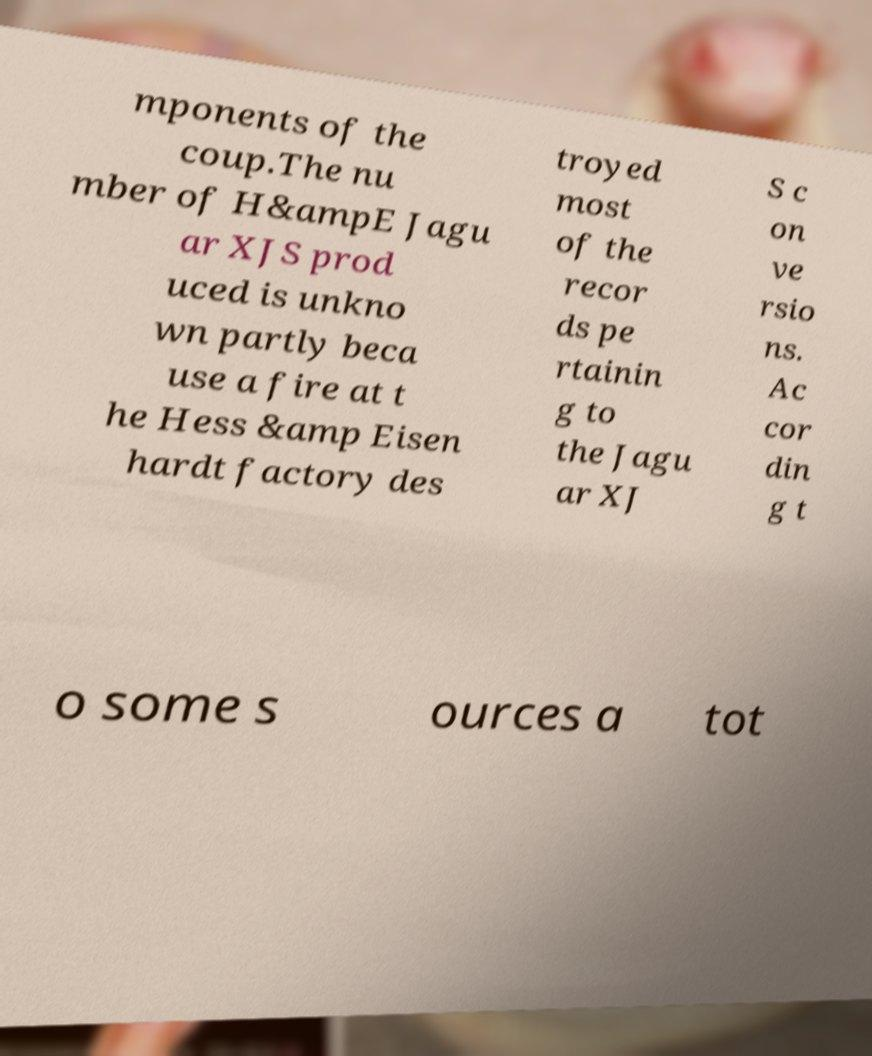Please identify and transcribe the text found in this image. mponents of the coup.The nu mber of H&ampE Jagu ar XJS prod uced is unkno wn partly beca use a fire at t he Hess &amp Eisen hardt factory des troyed most of the recor ds pe rtainin g to the Jagu ar XJ S c on ve rsio ns. Ac cor din g t o some s ources a tot 